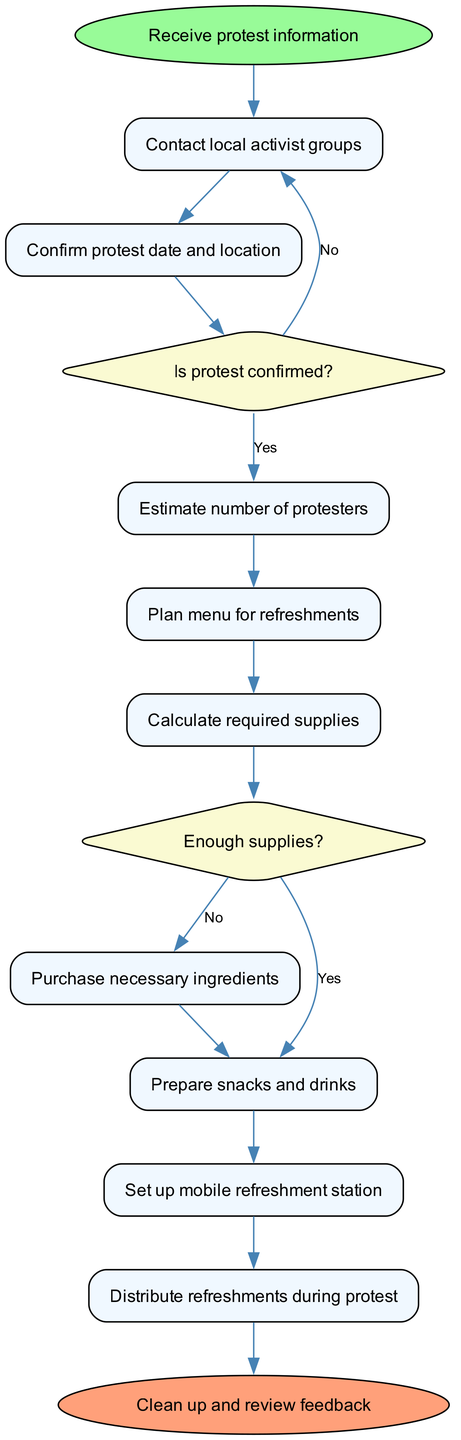What is the starting node of the diagram? The starting node, as indicated in the diagram, is "Receive protest information."
Answer: Receive protest information How many activities are listed in the diagram? Counting the activities shown in the diagram, there are a total of 8 activities.
Answer: 8 What happens after confirming the protest date and location? After confirming the protest date and location, the next step is to estimate the number of protesters.
Answer: Estimate number of protesters What decision comes after estimating the number of protesters? The decision that comes after estimating the number of protesters is whether the protest is confirmed or not.
Answer: Is protest confirmed? If supplies are not enough, what action needs to be taken? If the supplies are not enough, the action that needs to be taken is to purchase necessary ingredients.
Answer: Purchase necessary ingredients What is the last activity before the cleanup phase? The last activity before the cleanup phase is to distribute refreshments during the protest.
Answer: Distribute refreshments during protest What does the diagram indicate happens if the protest is not confirmed? If the protest is not confirmed, the diagram indicates to contact local activist groups.
Answer: Contact local activist groups What type of nodes represent decisions in the diagram? The decision nodes in the diagram are represented using diamond shapes.
Answer: Diamond shapes After preparing snacks and drinks, what is the subsequent activity? After preparing snacks and drinks, the subsequent activity is to set up the mobile refreshment station.
Answer: Set up mobile refreshment station 